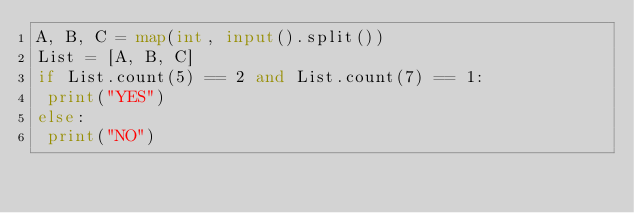Convert code to text. <code><loc_0><loc_0><loc_500><loc_500><_Python_>A, B, C = map(int, input().split())
List = [A, B, C]
if List.count(5) == 2 and List.count(7) == 1:
 print("YES")
else: 
 print("NO")</code> 